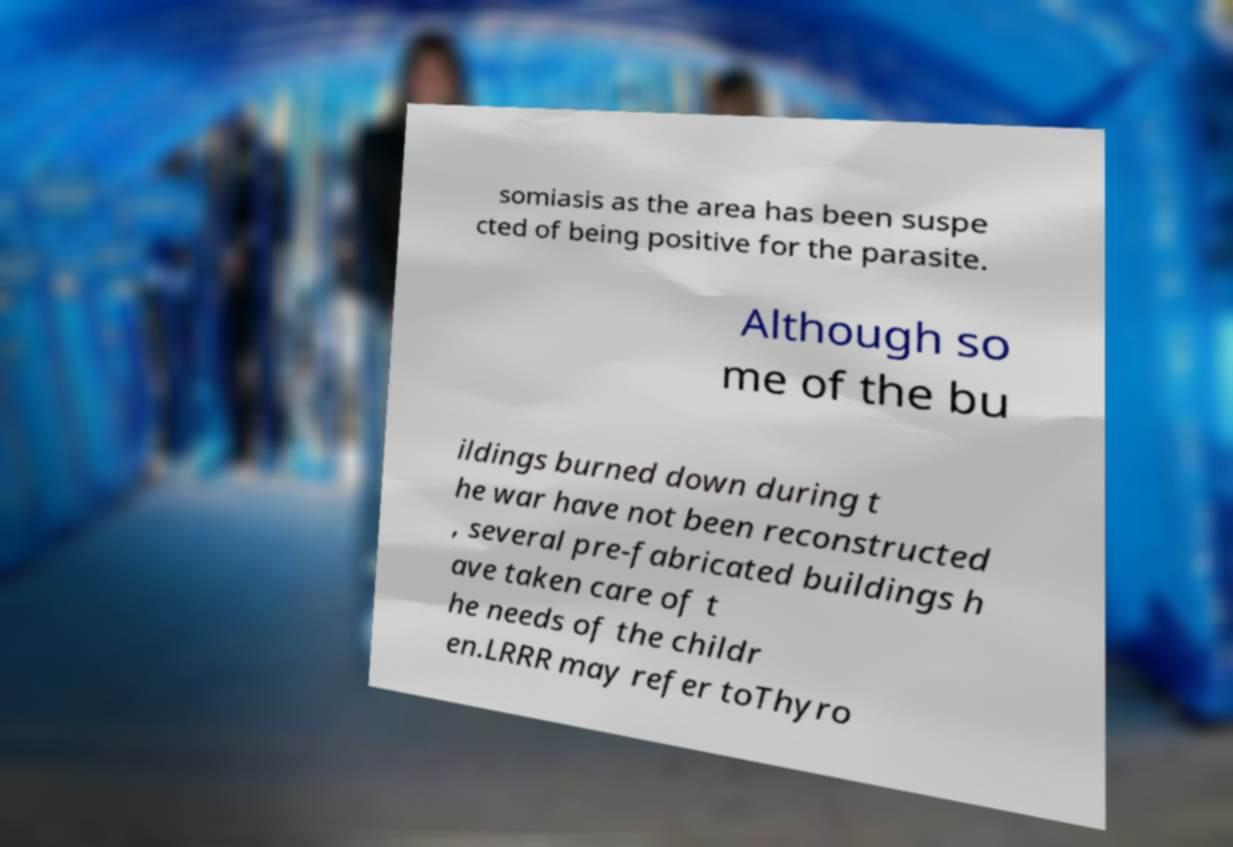Please identify and transcribe the text found in this image. somiasis as the area has been suspe cted of being positive for the parasite. Although so me of the bu ildings burned down during t he war have not been reconstructed , several pre-fabricated buildings h ave taken care of t he needs of the childr en.LRRR may refer toThyro 